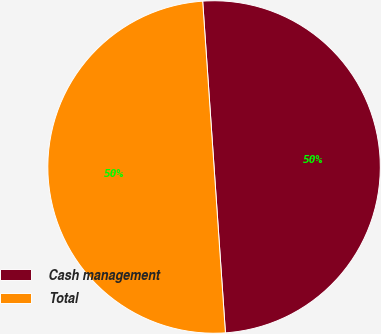Convert chart to OTSL. <chart><loc_0><loc_0><loc_500><loc_500><pie_chart><fcel>Cash management<fcel>Total<nl><fcel>50.0%<fcel>50.0%<nl></chart> 